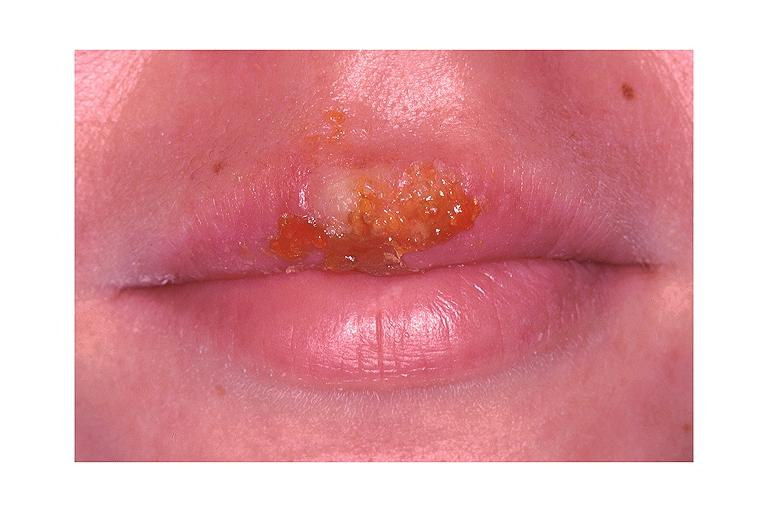does the unknown origin in mandible show recurrent herpes labialis?
Answer the question using a single word or phrase. No 